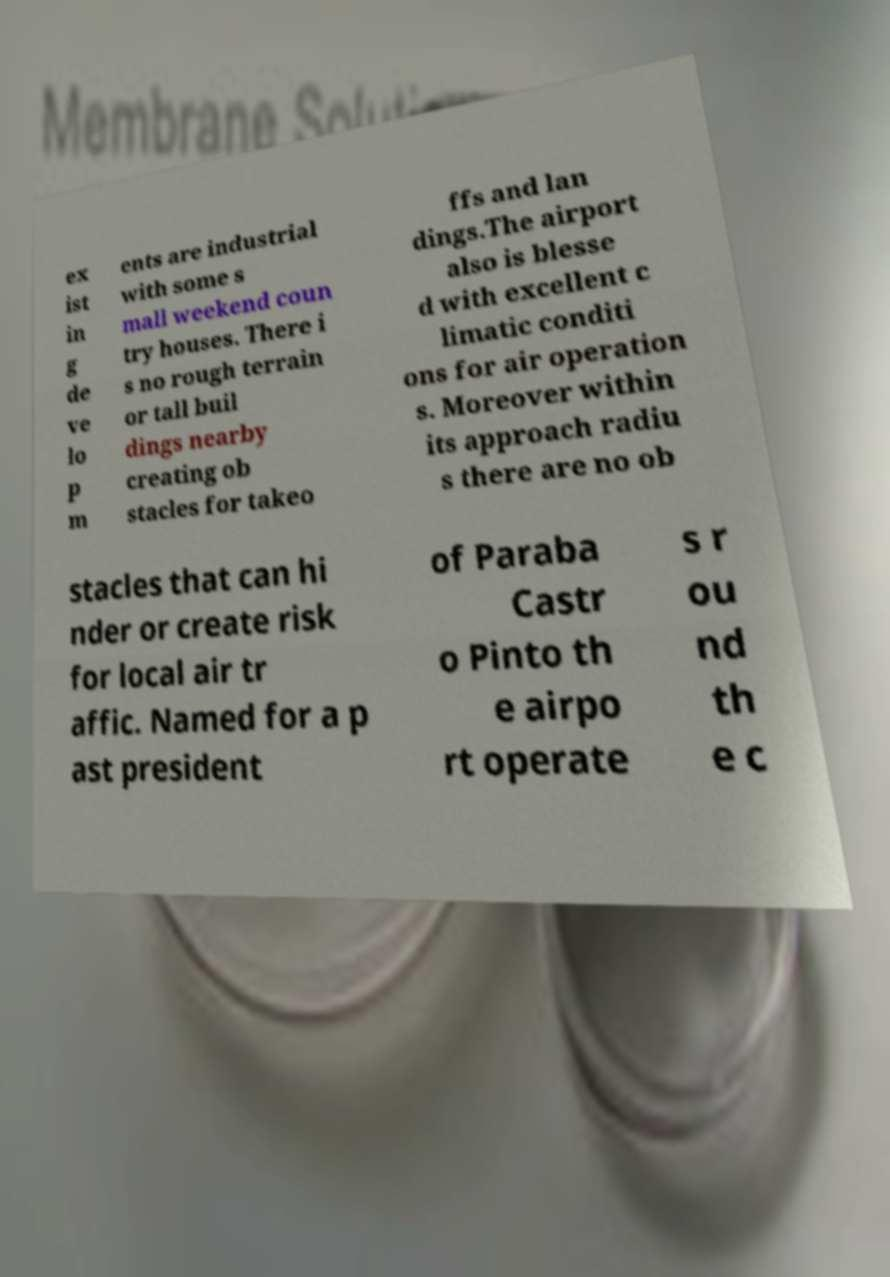For documentation purposes, I need the text within this image transcribed. Could you provide that? ex ist in g de ve lo p m ents are industrial with some s mall weekend coun try houses. There i s no rough terrain or tall buil dings nearby creating ob stacles for takeo ffs and lan dings.The airport also is blesse d with excellent c limatic conditi ons for air operation s. Moreover within its approach radiu s there are no ob stacles that can hi nder or create risk for local air tr affic. Named for a p ast president of Paraba Castr o Pinto th e airpo rt operate s r ou nd th e c 